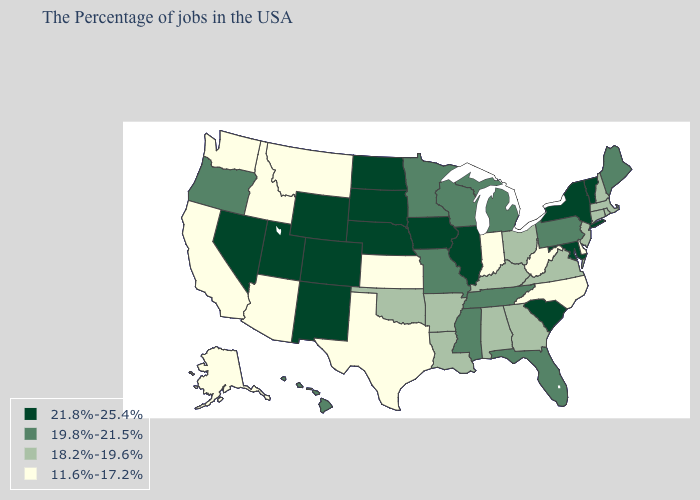What is the value of Alaska?
Be succinct. 11.6%-17.2%. What is the highest value in states that border Kentucky?
Write a very short answer. 21.8%-25.4%. Does the map have missing data?
Give a very brief answer. No. Name the states that have a value in the range 11.6%-17.2%?
Short answer required. Delaware, North Carolina, West Virginia, Indiana, Kansas, Texas, Montana, Arizona, Idaho, California, Washington, Alaska. Name the states that have a value in the range 18.2%-19.6%?
Short answer required. Massachusetts, Rhode Island, New Hampshire, Connecticut, New Jersey, Virginia, Ohio, Georgia, Kentucky, Alabama, Louisiana, Arkansas, Oklahoma. Name the states that have a value in the range 19.8%-21.5%?
Be succinct. Maine, Pennsylvania, Florida, Michigan, Tennessee, Wisconsin, Mississippi, Missouri, Minnesota, Oregon, Hawaii. What is the value of Rhode Island?
Be succinct. 18.2%-19.6%. What is the value of Georgia?
Give a very brief answer. 18.2%-19.6%. Among the states that border Florida , which have the lowest value?
Give a very brief answer. Georgia, Alabama. What is the value of Florida?
Quick response, please. 19.8%-21.5%. What is the value of South Dakota?
Quick response, please. 21.8%-25.4%. Name the states that have a value in the range 19.8%-21.5%?
Keep it brief. Maine, Pennsylvania, Florida, Michigan, Tennessee, Wisconsin, Mississippi, Missouri, Minnesota, Oregon, Hawaii. Name the states that have a value in the range 21.8%-25.4%?
Short answer required. Vermont, New York, Maryland, South Carolina, Illinois, Iowa, Nebraska, South Dakota, North Dakota, Wyoming, Colorado, New Mexico, Utah, Nevada. Name the states that have a value in the range 19.8%-21.5%?
Quick response, please. Maine, Pennsylvania, Florida, Michigan, Tennessee, Wisconsin, Mississippi, Missouri, Minnesota, Oregon, Hawaii. Does Iowa have the same value as Massachusetts?
Short answer required. No. 